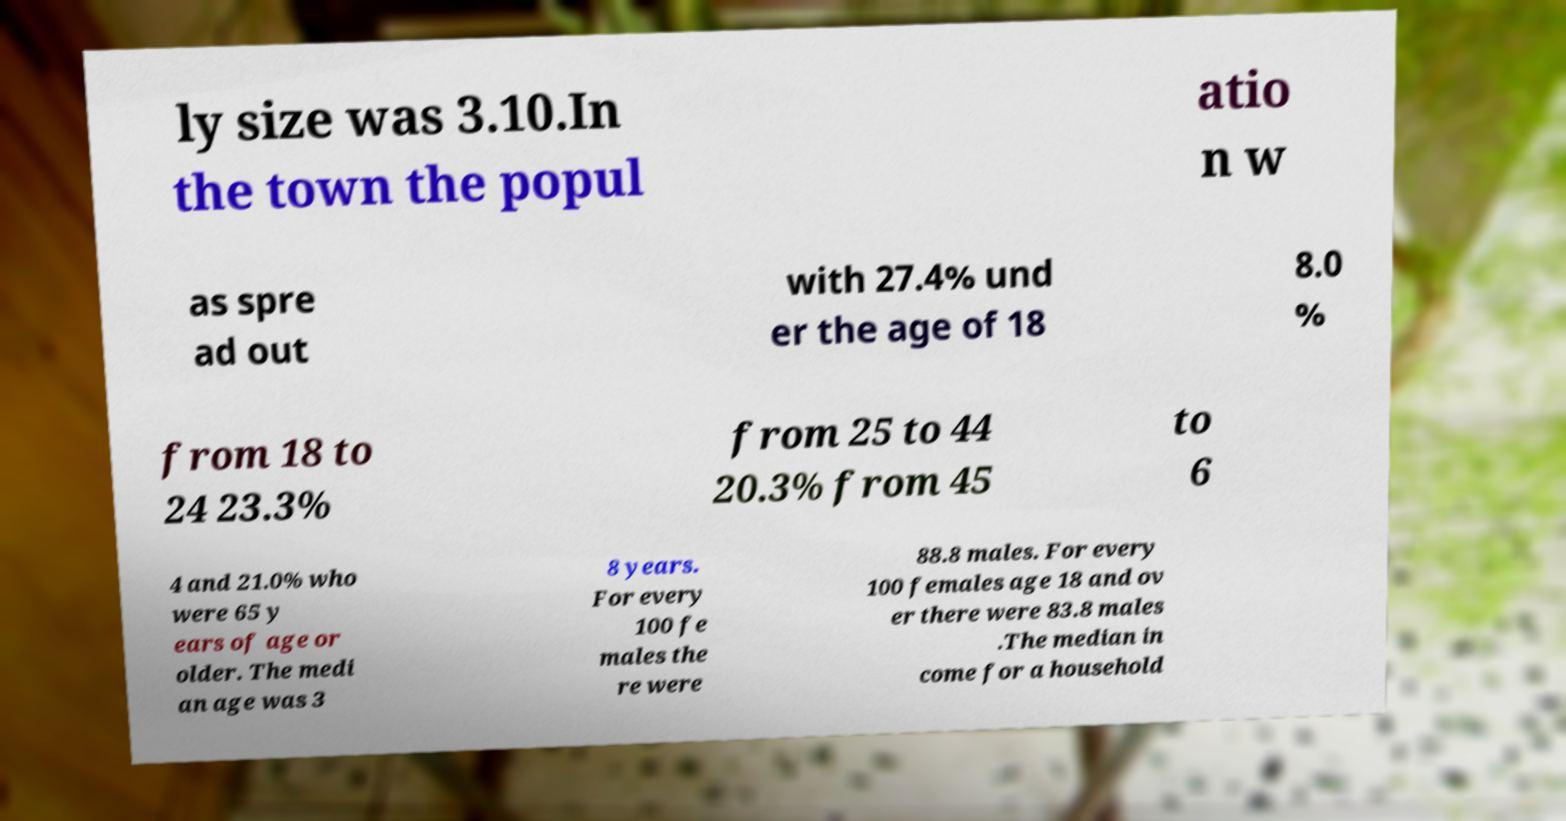What messages or text are displayed in this image? I need them in a readable, typed format. ly size was 3.10.In the town the popul atio n w as spre ad out with 27.4% und er the age of 18 8.0 % from 18 to 24 23.3% from 25 to 44 20.3% from 45 to 6 4 and 21.0% who were 65 y ears of age or older. The medi an age was 3 8 years. For every 100 fe males the re were 88.8 males. For every 100 females age 18 and ov er there were 83.8 males .The median in come for a household 